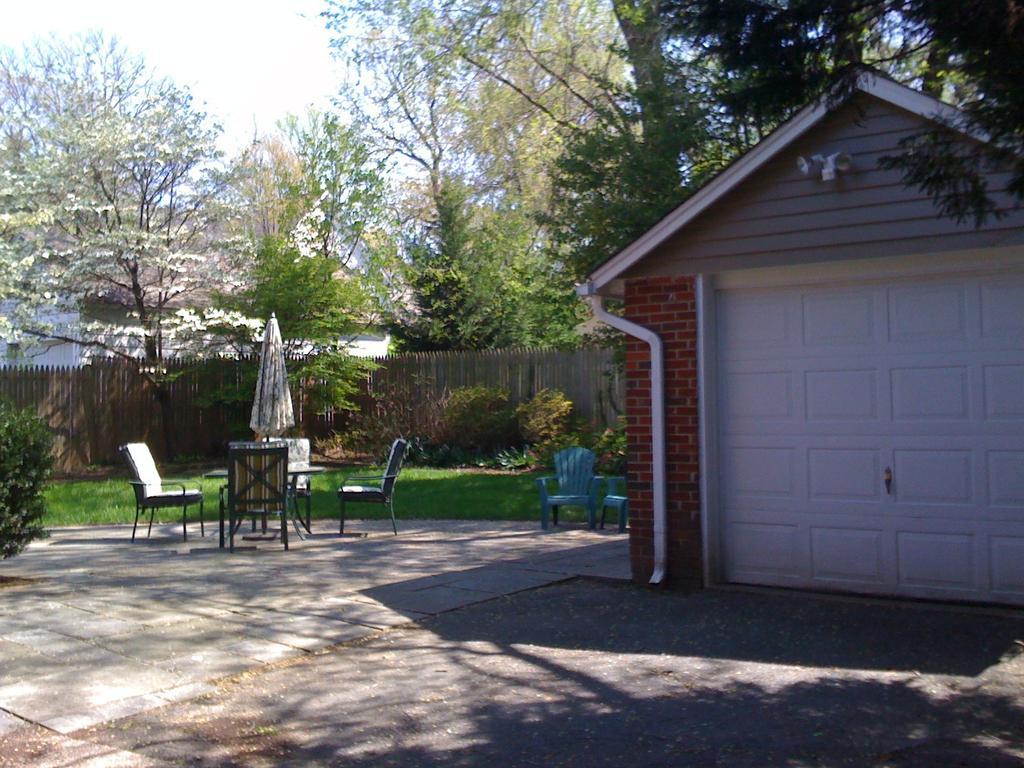How would you summarize this image in a sentence or two? In this image we can see chairs and table. There are trees at the background of the image. There is a fencing. There is a house. At the bottom of the image there is road. There is a umbrella. 